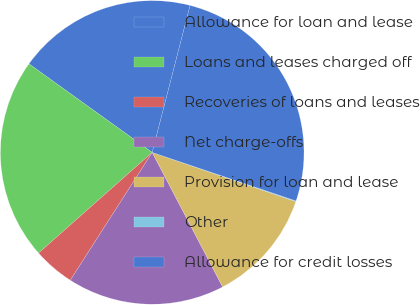Convert chart to OTSL. <chart><loc_0><loc_0><loc_500><loc_500><pie_chart><fcel>Allowance for loan and lease<fcel>Loans and leases charged off<fcel>Recoveries of loans and leases<fcel>Net charge-offs<fcel>Provision for loan and lease<fcel>Other<fcel>Allowance for credit losses<nl><fcel>19.1%<fcel>21.45%<fcel>4.39%<fcel>16.75%<fcel>12.07%<fcel>0.08%<fcel>26.16%<nl></chart> 